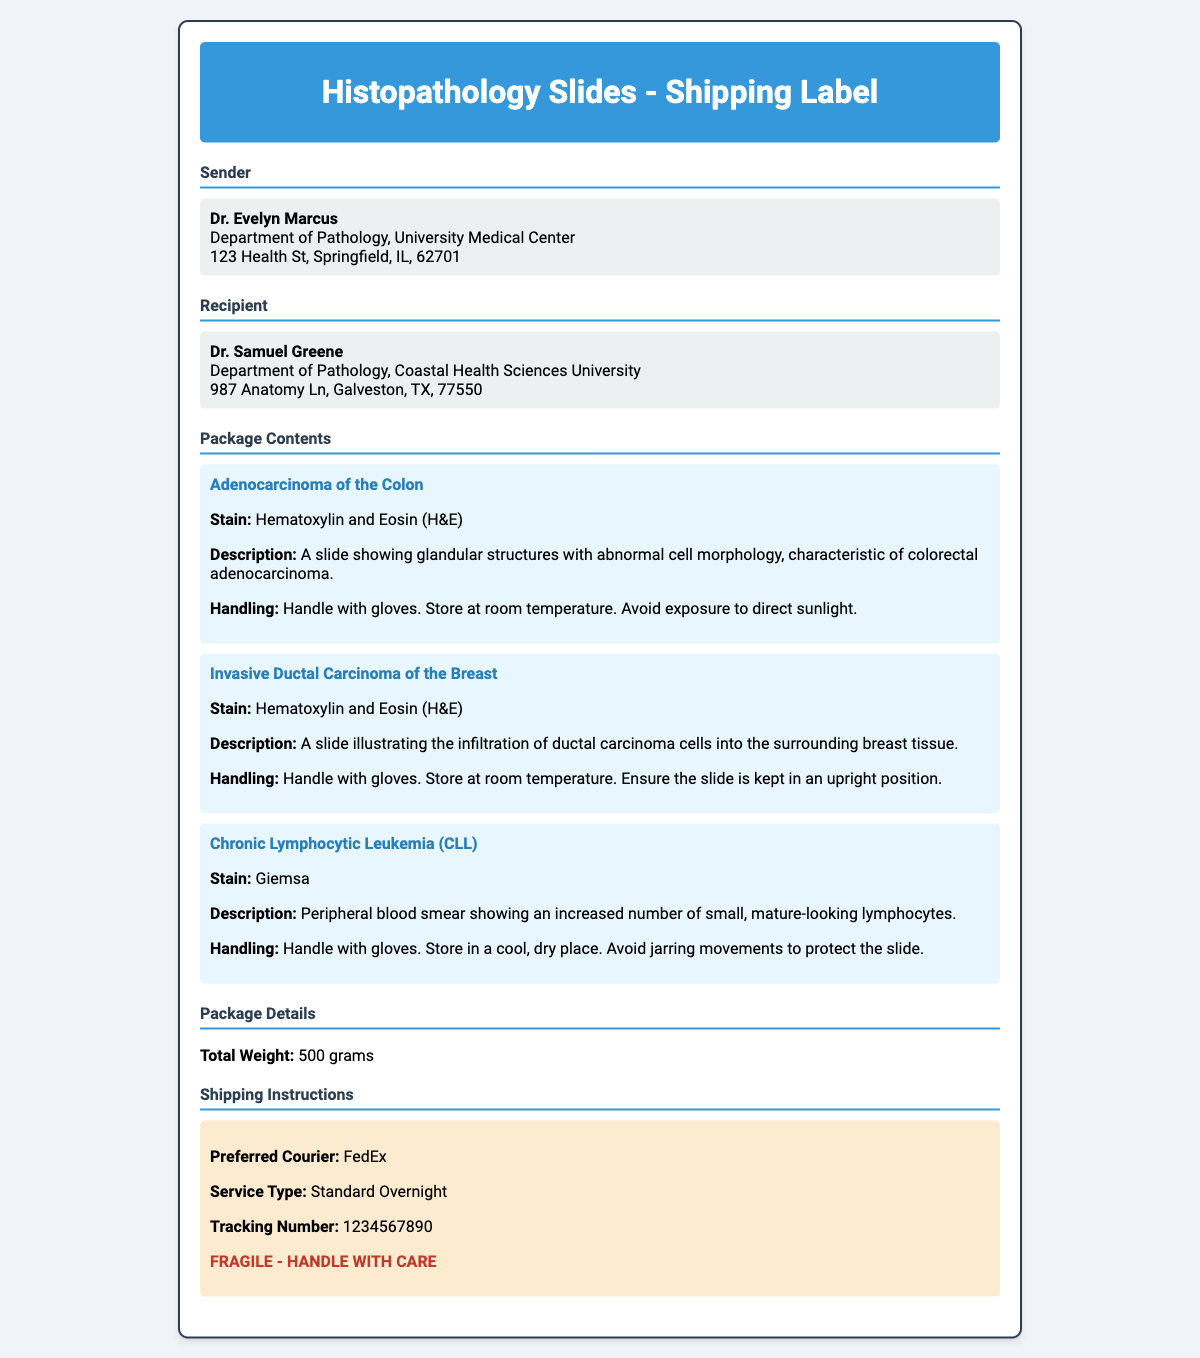What is the sender's name? The sender's name listed in the document is Dr. Evelyn Marcus.
Answer: Dr. Evelyn Marcus What is the recipient's name? The recipient's name listed in the document is Dr. Samuel Greene.
Answer: Dr. Samuel Greene How many slides are included in the package? The document details three specific slides included in the package.
Answer: Three What is the stain used for the Adenocarcinoma slide? The stain detailed for the Adenocarcinoma of the Colon slide is Hematoxylin and Eosin (H&E).
Answer: Hematoxylin and Eosin (H&E) What is the total weight of the package? The total weight of the package is explicitly mentioned in the document.
Answer: 500 grams What handling instruction is common for all slides? A common handling instruction for all slides is to handle with gloves.
Answer: Handle with gloves What is the preferred courier for shipping? The preferred courier mentioned in the document for shipping is FedEx.
Answer: FedEx What is the service type for shipping? The service type for shipping specified in the document is Standard Overnight.
Answer: Standard Overnight What specific warning is noted on the shipping label? A specific warning noted in the shipping instructions is that the package is fragile and should be handled with care.
Answer: FRAGILE - HANDLE WITH CARE 